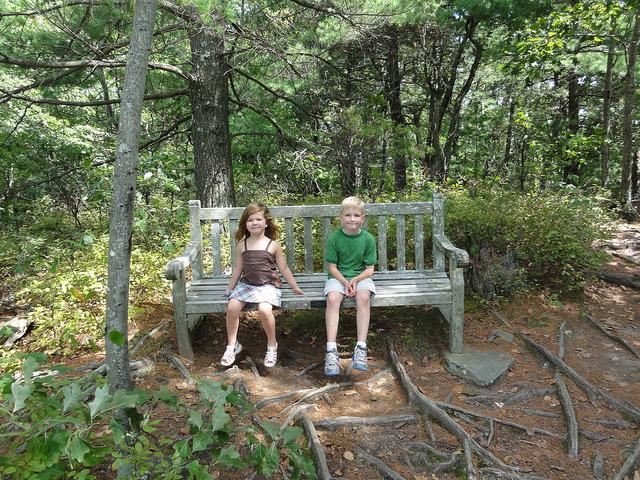What could likely happen to you on this bench?

Choices:
A) get seasick
B) get sunburn
C) get lost
D) sandy feet get sunburn 